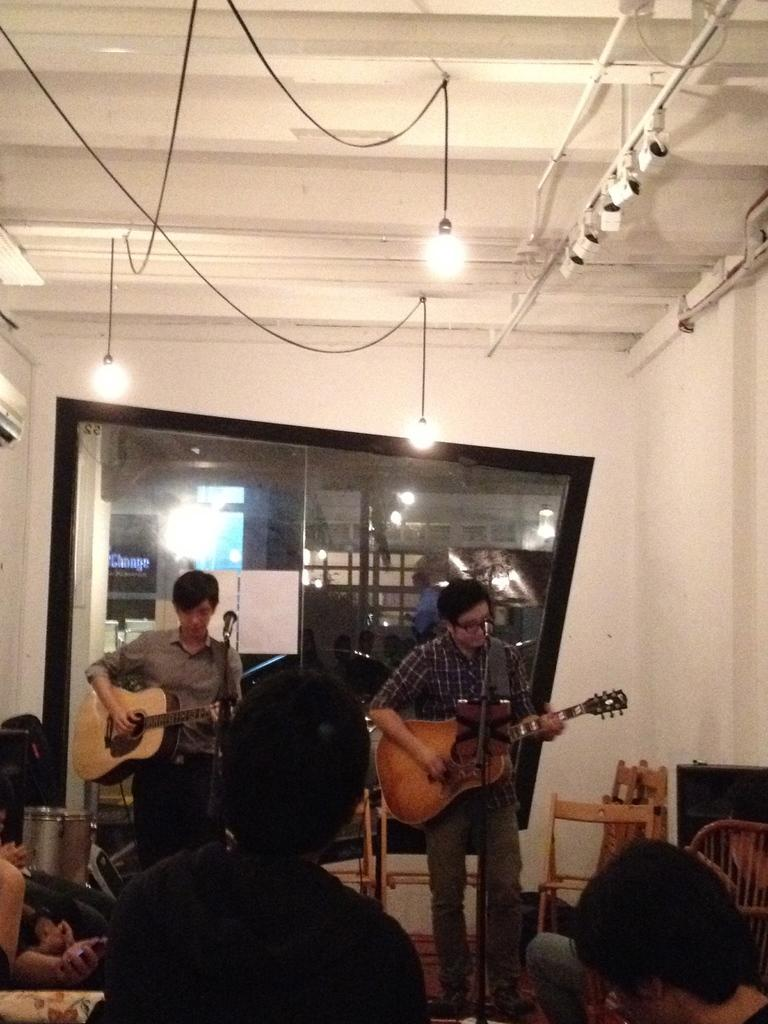How many people are playing guitars in the image? There are 2 persons standing in the image, and they are playing guitars. What equipment is near the persons playing guitars? There is a microphone near the persons. Can you describe the background of the image? In the background, there is a group of people, a couch, chairs, a speaker, lights, a door, and drums. What is the mass of the furniture in the image? There is no specific furniture mentioned in the image, so it is not possible to determine its mass. 